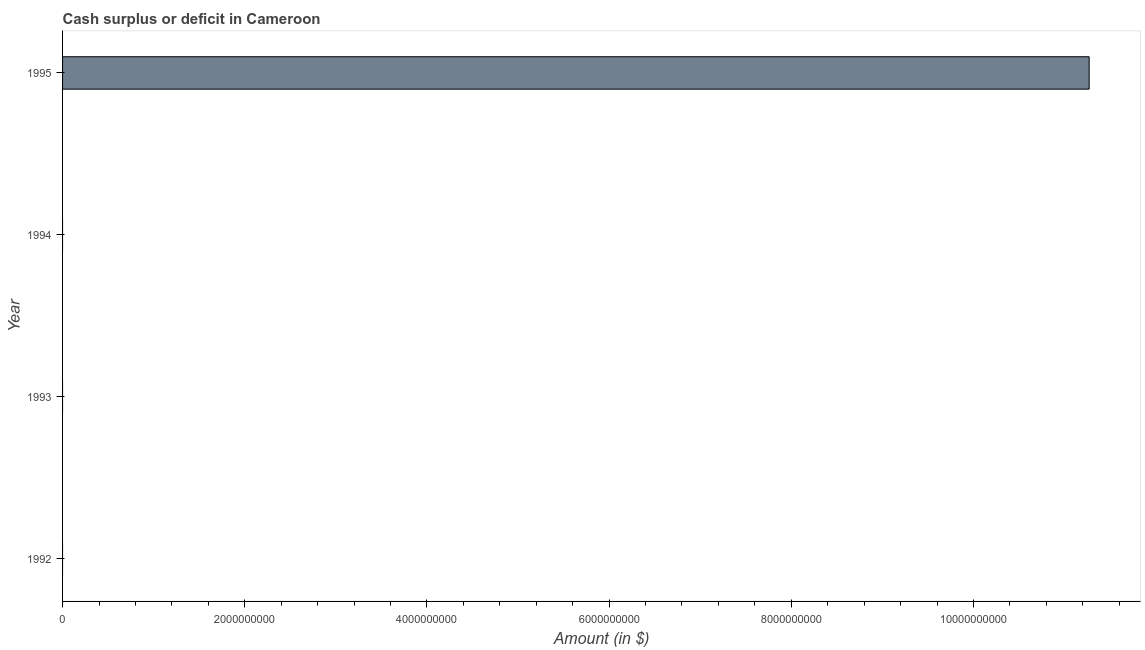Does the graph contain any zero values?
Your answer should be very brief. Yes. Does the graph contain grids?
Offer a very short reply. No. What is the title of the graph?
Offer a very short reply. Cash surplus or deficit in Cameroon. What is the label or title of the X-axis?
Offer a very short reply. Amount (in $). Across all years, what is the maximum cash surplus or deficit?
Your answer should be very brief. 1.13e+1. Across all years, what is the minimum cash surplus or deficit?
Your answer should be very brief. 0. What is the sum of the cash surplus or deficit?
Keep it short and to the point. 1.13e+1. What is the average cash surplus or deficit per year?
Offer a very short reply. 2.82e+09. What is the difference between the highest and the lowest cash surplus or deficit?
Provide a short and direct response. 1.13e+1. How many bars are there?
Offer a very short reply. 1. Are all the bars in the graph horizontal?
Make the answer very short. Yes. What is the difference between two consecutive major ticks on the X-axis?
Offer a terse response. 2.00e+09. Are the values on the major ticks of X-axis written in scientific E-notation?
Give a very brief answer. No. What is the Amount (in $) of 1992?
Keep it short and to the point. 0. What is the Amount (in $) of 1994?
Offer a terse response. 0. What is the Amount (in $) of 1995?
Keep it short and to the point. 1.13e+1. 